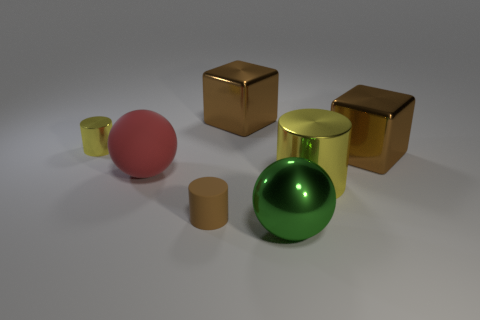How many metal things are either cylinders or balls?
Provide a short and direct response. 3. Is the rubber sphere the same size as the green thing?
Give a very brief answer. Yes. Is the number of brown metal things in front of the big red ball less than the number of brown things in front of the large green thing?
Provide a succinct answer. No. Are there any other things that have the same size as the red object?
Your answer should be compact. Yes. The green shiny thing is what size?
Provide a succinct answer. Large. How many tiny objects are red rubber blocks or brown rubber objects?
Your response must be concise. 1. There is a brown rubber cylinder; is it the same size as the cylinder on the left side of the big red matte sphere?
Provide a succinct answer. Yes. Is there any other thing that is the same shape as the small brown thing?
Provide a short and direct response. Yes. What number of large red matte cylinders are there?
Your answer should be compact. 0. How many yellow objects are either matte cylinders or tiny things?
Provide a succinct answer. 1. 